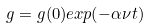<formula> <loc_0><loc_0><loc_500><loc_500>g = g ( 0 ) e x p ( - \alpha \nu t )</formula> 